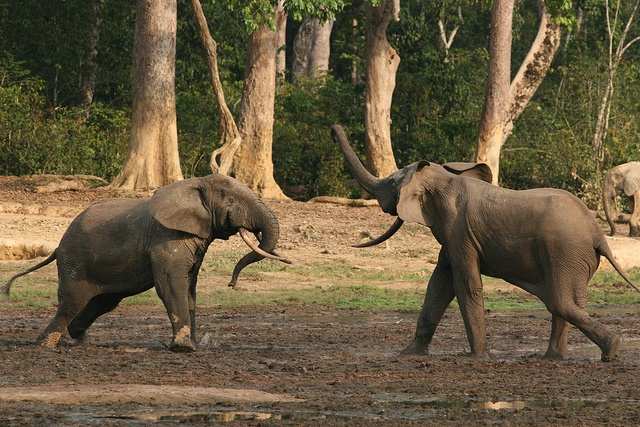Describe the objects in this image and their specific colors. I can see elephant in black, maroon, gray, and tan tones, elephant in black and gray tones, and elephant in black, tan, and gray tones in this image. 